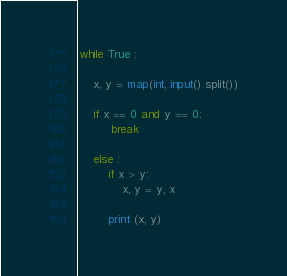<code> <loc_0><loc_0><loc_500><loc_500><_Python_>while True :

    x, y = map(int, input().split())
    
    if x == 0 and y == 0:
         break
   
    else :
        if x > y:
            x, y = y, x
    
        print (x, y)
</code> 